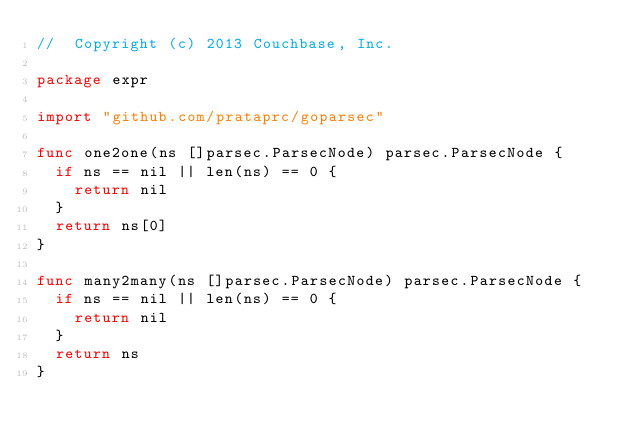<code> <loc_0><loc_0><loc_500><loc_500><_Go_>//  Copyright (c) 2013 Couchbase, Inc.

package expr

import "github.com/prataprc/goparsec"

func one2one(ns []parsec.ParsecNode) parsec.ParsecNode {
	if ns == nil || len(ns) == 0 {
		return nil
	}
	return ns[0]
}

func many2many(ns []parsec.ParsecNode) parsec.ParsecNode {
	if ns == nil || len(ns) == 0 {
		return nil
	}
	return ns
}
</code> 